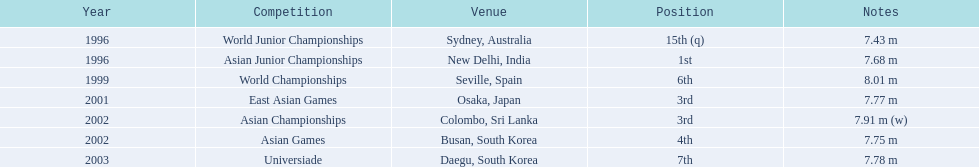In what events did huang le compete? World Junior Championships, Asian Junior Championships, World Championships, East Asian Games, Asian Championships, Asian Games, Universiade. What distances did he reach in these events? 7.43 m, 7.68 m, 8.01 m, 7.77 m, 7.91 m (w), 7.75 m, 7.78 m. Which of these distances was the most significant? 7.91 m (w). 